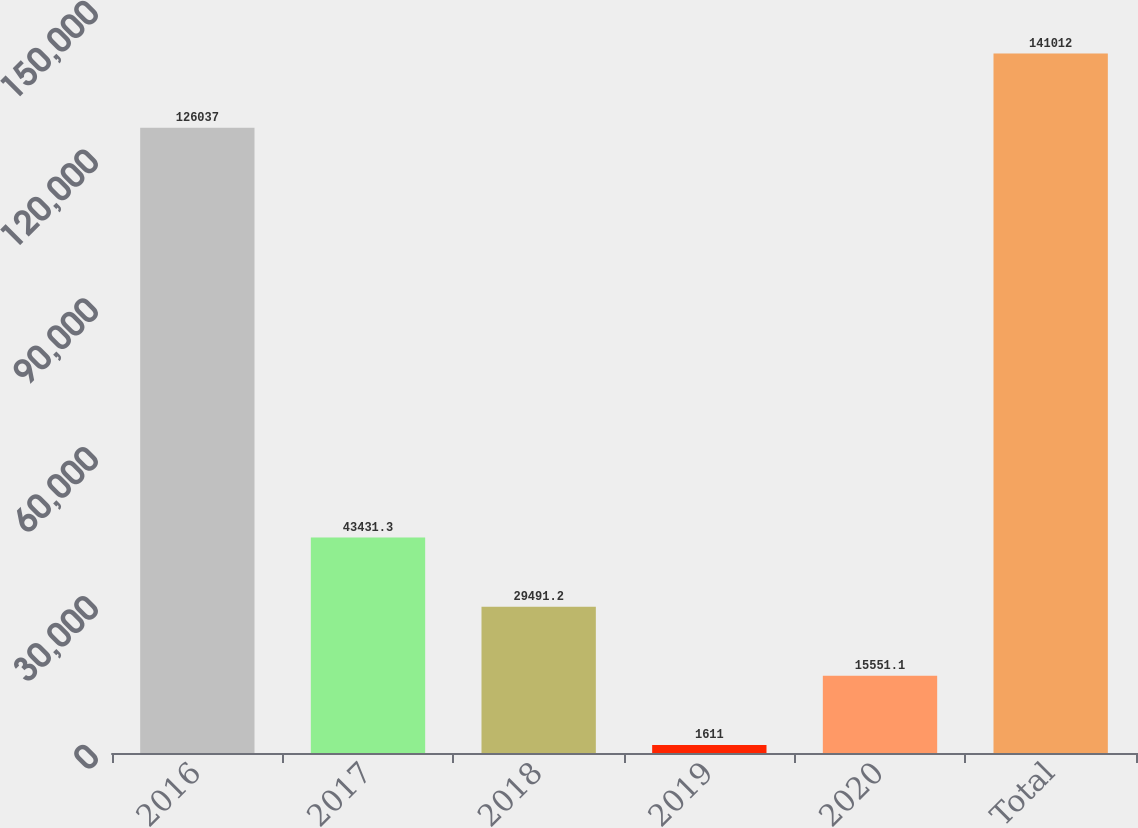Convert chart to OTSL. <chart><loc_0><loc_0><loc_500><loc_500><bar_chart><fcel>2016<fcel>2017<fcel>2018<fcel>2019<fcel>2020<fcel>Total<nl><fcel>126037<fcel>43431.3<fcel>29491.2<fcel>1611<fcel>15551.1<fcel>141012<nl></chart> 